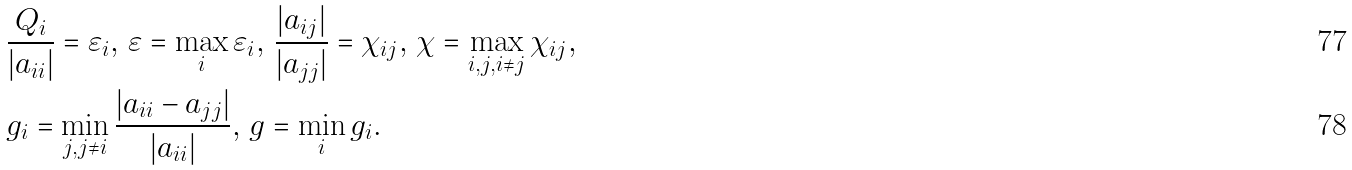<formula> <loc_0><loc_0><loc_500><loc_500>& \frac { Q _ { i } } { | a _ { i i } | } = \varepsilon _ { i } , \, \varepsilon = \max _ { i } \varepsilon _ { i } , \, \frac { | a _ { i j } | } { | a _ { j j } | } = \chi _ { i j } , \, \chi = \max _ { i , j , i \neq j } \chi _ { i j } , \\ & g _ { i } = \min _ { j , j \neq i } \frac { | a _ { i i } - a _ { j j } | } { | a _ { i i } | } , \, g = \min _ { i } g _ { i } .</formula> 